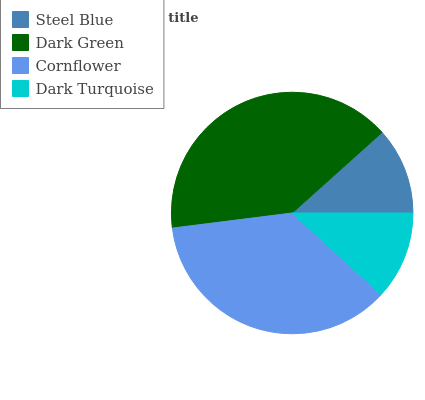Is Steel Blue the minimum?
Answer yes or no. Yes. Is Dark Green the maximum?
Answer yes or no. Yes. Is Cornflower the minimum?
Answer yes or no. No. Is Cornflower the maximum?
Answer yes or no. No. Is Dark Green greater than Cornflower?
Answer yes or no. Yes. Is Cornflower less than Dark Green?
Answer yes or no. Yes. Is Cornflower greater than Dark Green?
Answer yes or no. No. Is Dark Green less than Cornflower?
Answer yes or no. No. Is Cornflower the high median?
Answer yes or no. Yes. Is Dark Turquoise the low median?
Answer yes or no. Yes. Is Dark Turquoise the high median?
Answer yes or no. No. Is Steel Blue the low median?
Answer yes or no. No. 